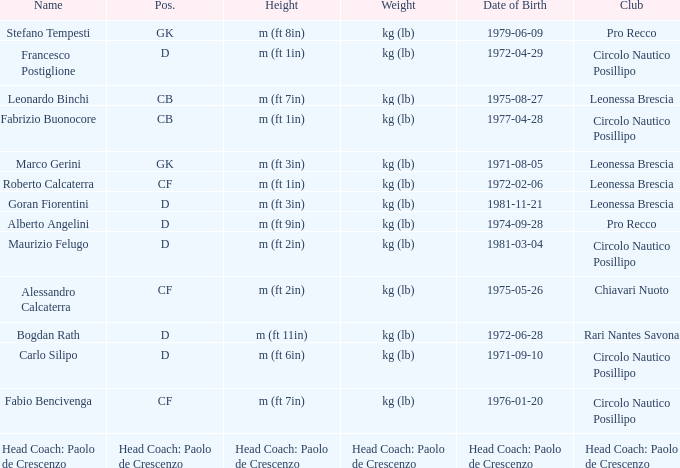What is the mass of the entry with a birth date of 1981-11-21? Kg (lb). 